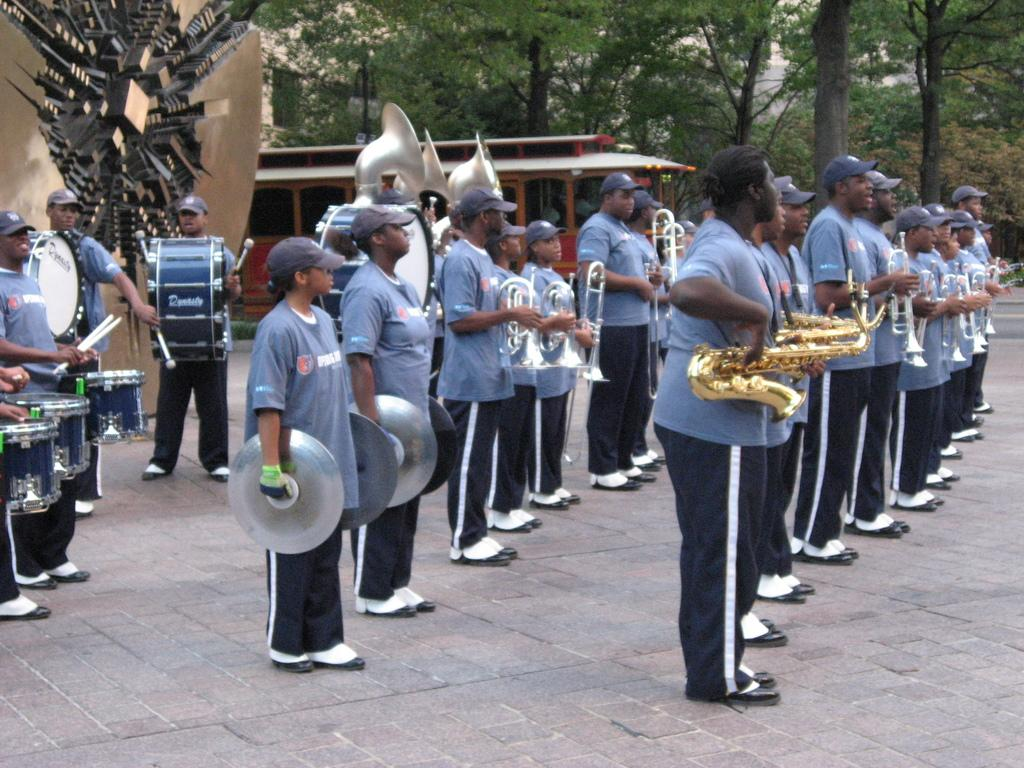What type of natural scenery can be seen in the background of the image? There are trees in the background of the image. What type of structure is visible in the background of the image? There is a house in the background of the image. What architectural feature is present in the image? There is an arch in the image. What are the people in the image doing? The people are playing musical instruments. What type of milk is being used in the image? There is no milk present in the image. 